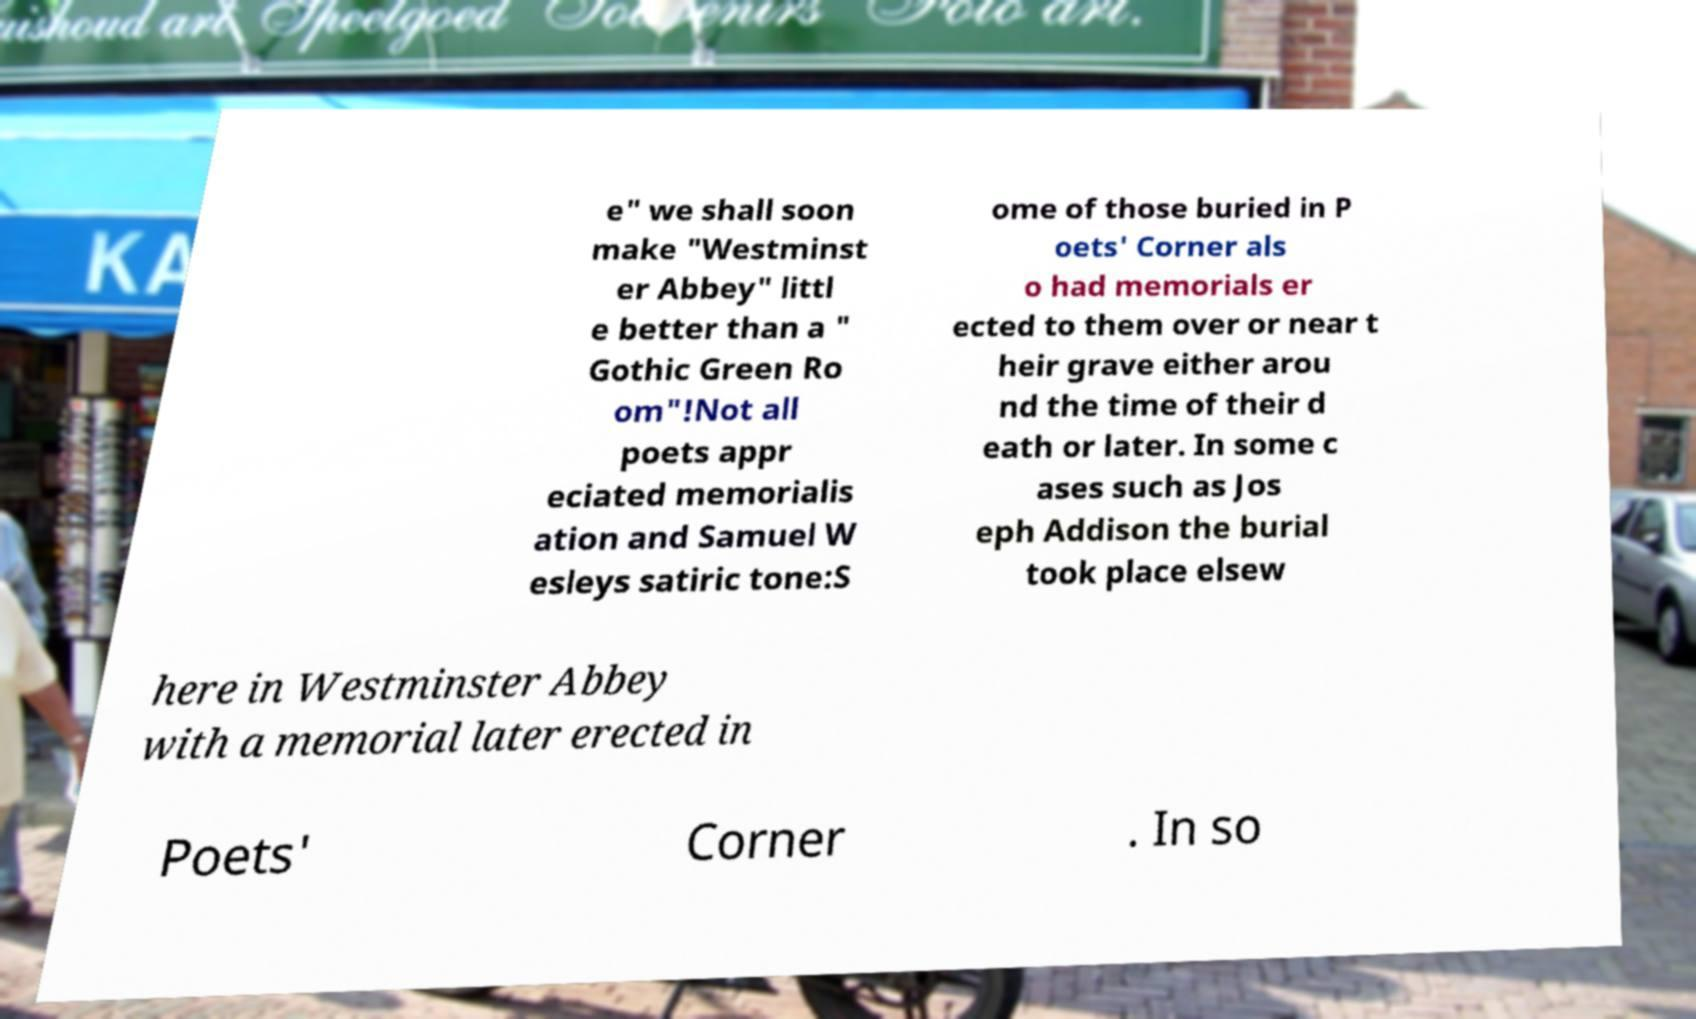For documentation purposes, I need the text within this image transcribed. Could you provide that? e" we shall soon make "Westminst er Abbey" littl e better than a " Gothic Green Ro om"!Not all poets appr eciated memorialis ation and Samuel W esleys satiric tone:S ome of those buried in P oets' Corner als o had memorials er ected to them over or near t heir grave either arou nd the time of their d eath or later. In some c ases such as Jos eph Addison the burial took place elsew here in Westminster Abbey with a memorial later erected in Poets' Corner . In so 